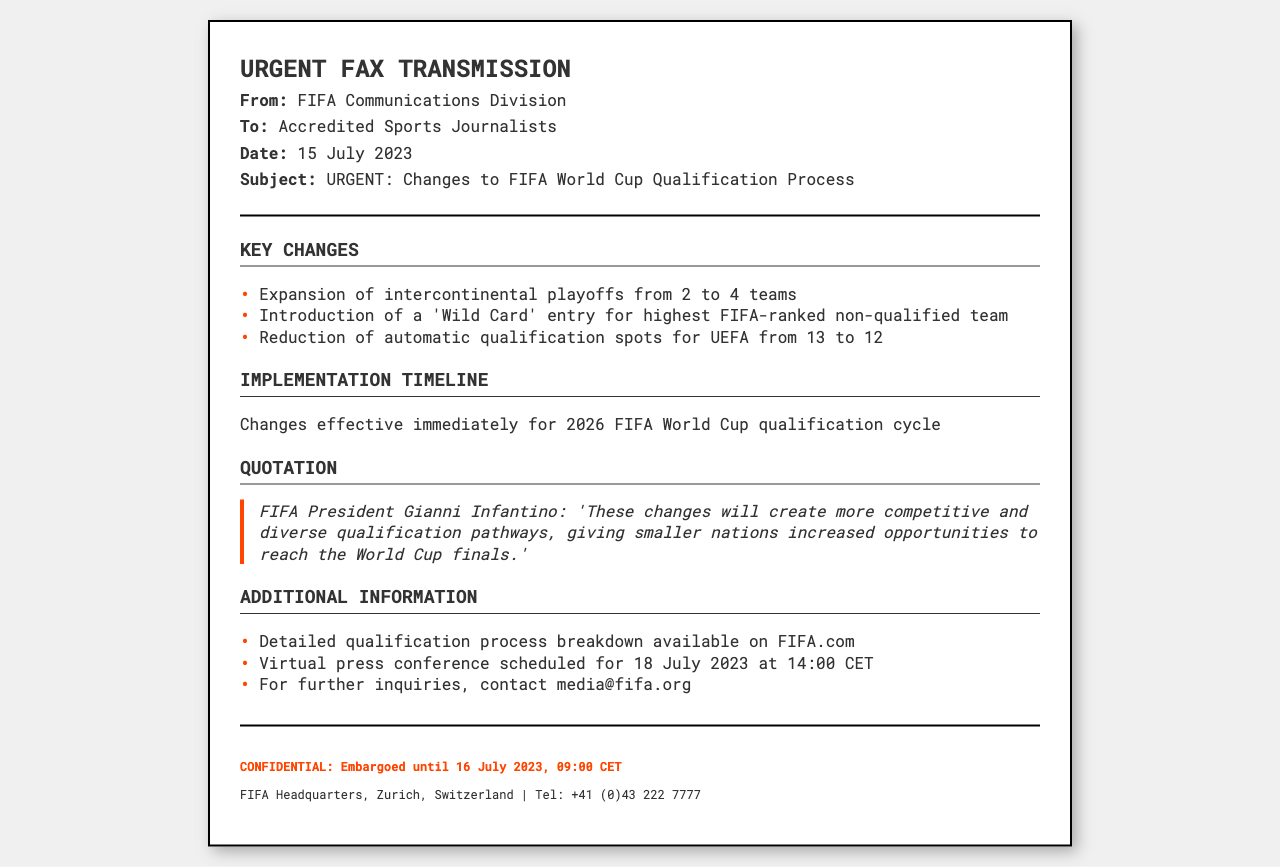What is the date of the fax? The date of the fax is provided in the header section of the document.
Answer: 15 July 2023 Who is the sender of the fax? The sender of the fax is mentioned in the header section as the FIFA Communications Division.
Answer: FIFA Communications Division How many automatic qualification spots will UEFA have after the change? The document specifies the reduction in automatic qualification spots for UEFA.
Answer: 12 What new entry has been introduced for the qualification process? The document mentions a specific new entry type in the key changes section.
Answer: 'Wild Card' entry When is the virtual press conference scheduled? The date and time for the virtual press conference is mentioned in the additional information section.
Answer: 18 July 2023 at 14:00 CET What is the effect of the changes on the intercontinental playoffs? The document describes a specific change regarding the number of intercontinental playoff teams.
Answer: From 2 to 4 teams What does FIFA President Gianni Infantino say about the changes? The quote from the FIFA President provides insight into the purpose of the changes.
Answer: "These changes will create more competitive and diverse qualification pathways, giving smaller nations increased opportunities to reach the World Cup finals." What is the nature of the document? The structure and content indicate the type of information conveyed in the document.
Answer: Urgent Fax Transmission 